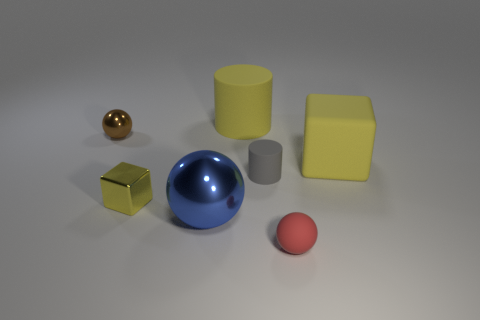Add 2 tiny gray balls. How many objects exist? 9 Subtract all spheres. How many objects are left? 4 Add 1 yellow cylinders. How many yellow cylinders are left? 2 Add 1 small red metallic cubes. How many small red metallic cubes exist? 1 Subtract 0 purple blocks. How many objects are left? 7 Subtract all big gray metal cubes. Subtract all yellow objects. How many objects are left? 4 